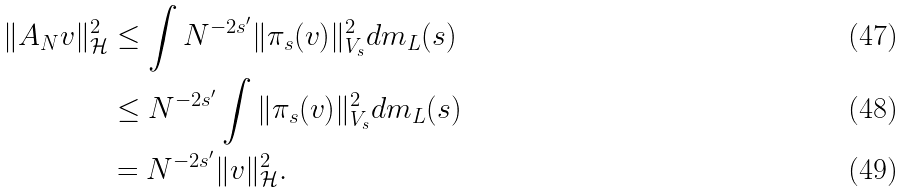<formula> <loc_0><loc_0><loc_500><loc_500>\| A _ { N } v \| _ { \mathcal { H } } ^ { 2 } & \leq \int N ^ { - 2 s ^ { \prime } } \| \pi _ { s } ( v ) \| _ { V _ { s } } ^ { 2 } d m _ { L } ( s ) \\ & \leq N ^ { - 2 s ^ { \prime } } \int \| \pi _ { s } ( v ) \| _ { V _ { s } } ^ { 2 } d m _ { L } ( s ) \\ & = N ^ { - 2 s ^ { \prime } } \| v \| _ { \mathcal { H } } ^ { 2 } .</formula> 